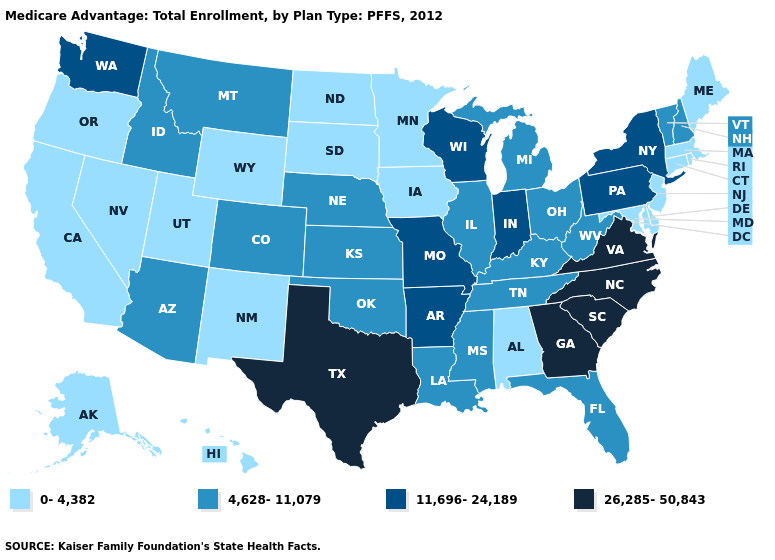Name the states that have a value in the range 26,285-50,843?
Short answer required. Georgia, North Carolina, South Carolina, Texas, Virginia. Among the states that border Louisiana , does Texas have the lowest value?
Short answer required. No. Name the states that have a value in the range 26,285-50,843?
Concise answer only. Georgia, North Carolina, South Carolina, Texas, Virginia. Name the states that have a value in the range 0-4,382?
Keep it brief. Alaska, Alabama, California, Connecticut, Delaware, Hawaii, Iowa, Massachusetts, Maryland, Maine, Minnesota, North Dakota, New Jersey, New Mexico, Nevada, Oregon, Rhode Island, South Dakota, Utah, Wyoming. What is the highest value in states that border Arkansas?
Quick response, please. 26,285-50,843. Name the states that have a value in the range 4,628-11,079?
Short answer required. Arizona, Colorado, Florida, Idaho, Illinois, Kansas, Kentucky, Louisiana, Michigan, Mississippi, Montana, Nebraska, New Hampshire, Ohio, Oklahoma, Tennessee, Vermont, West Virginia. Does Tennessee have the lowest value in the USA?
Concise answer only. No. Does Alaska have a higher value than Nebraska?
Short answer required. No. Does South Carolina have the highest value in the South?
Give a very brief answer. Yes. What is the value of Alaska?
Short answer required. 0-4,382. Name the states that have a value in the range 26,285-50,843?
Answer briefly. Georgia, North Carolina, South Carolina, Texas, Virginia. Name the states that have a value in the range 0-4,382?
Quick response, please. Alaska, Alabama, California, Connecticut, Delaware, Hawaii, Iowa, Massachusetts, Maryland, Maine, Minnesota, North Dakota, New Jersey, New Mexico, Nevada, Oregon, Rhode Island, South Dakota, Utah, Wyoming. Name the states that have a value in the range 11,696-24,189?
Concise answer only. Arkansas, Indiana, Missouri, New York, Pennsylvania, Washington, Wisconsin. How many symbols are there in the legend?
Quick response, please. 4. What is the highest value in the USA?
Short answer required. 26,285-50,843. 